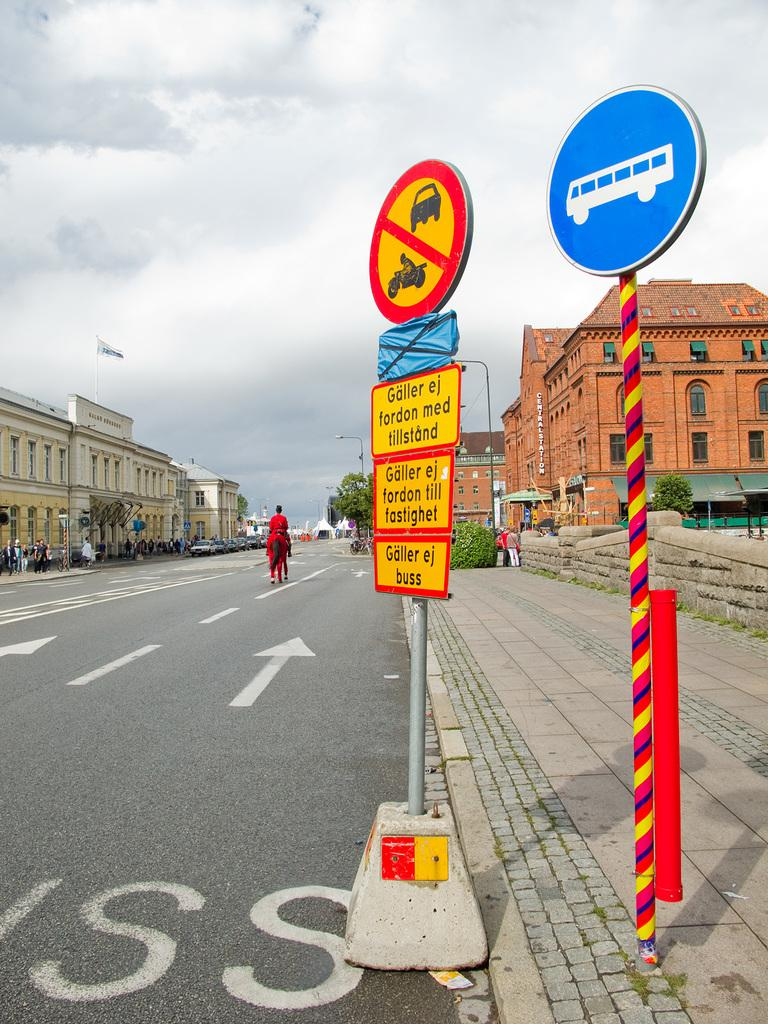<image>
Create a compact narrative representing the image presented. The signs warns many things such as Galler ej buss. 